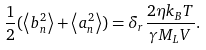Convert formula to latex. <formula><loc_0><loc_0><loc_500><loc_500>\frac { 1 } { 2 } ( \left \langle b _ { n } ^ { 2 } \right \rangle + \left \langle a _ { n } ^ { 2 } \right \rangle ) = \delta _ { r } \frac { 2 \eta k _ { B } T } { \gamma M _ { L } V } .</formula> 